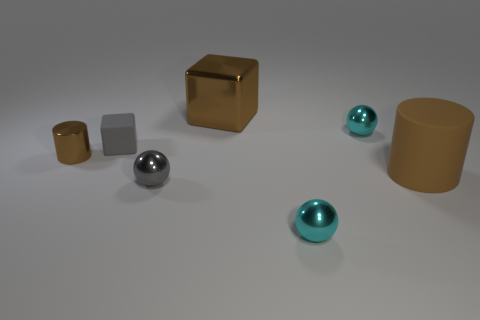There is a matte block; does it have the same color as the cylinder on the left side of the small matte object?
Offer a very short reply. No. Are there any brown rubber things behind the brown shiny cylinder?
Your answer should be compact. No. Does the large cylinder have the same material as the big cube?
Ensure brevity in your answer.  No. What material is the block that is the same size as the shiny cylinder?
Make the answer very short. Rubber. What number of objects are brown metal things that are to the left of the brown metallic cube or brown metal cubes?
Ensure brevity in your answer.  2. Are there the same number of cyan objects in front of the tiny gray cube and large brown shiny things?
Provide a short and direct response. Yes. Is the color of the big cube the same as the rubber cube?
Offer a very short reply. No. What is the color of the small thing that is both behind the small gray metal thing and on the right side of the large brown shiny block?
Give a very brief answer. Cyan. How many balls are either large metal objects or tiny gray rubber objects?
Give a very brief answer. 0. Is the number of small brown metal objects behind the small gray matte object less than the number of big things?
Your answer should be very brief. Yes. 